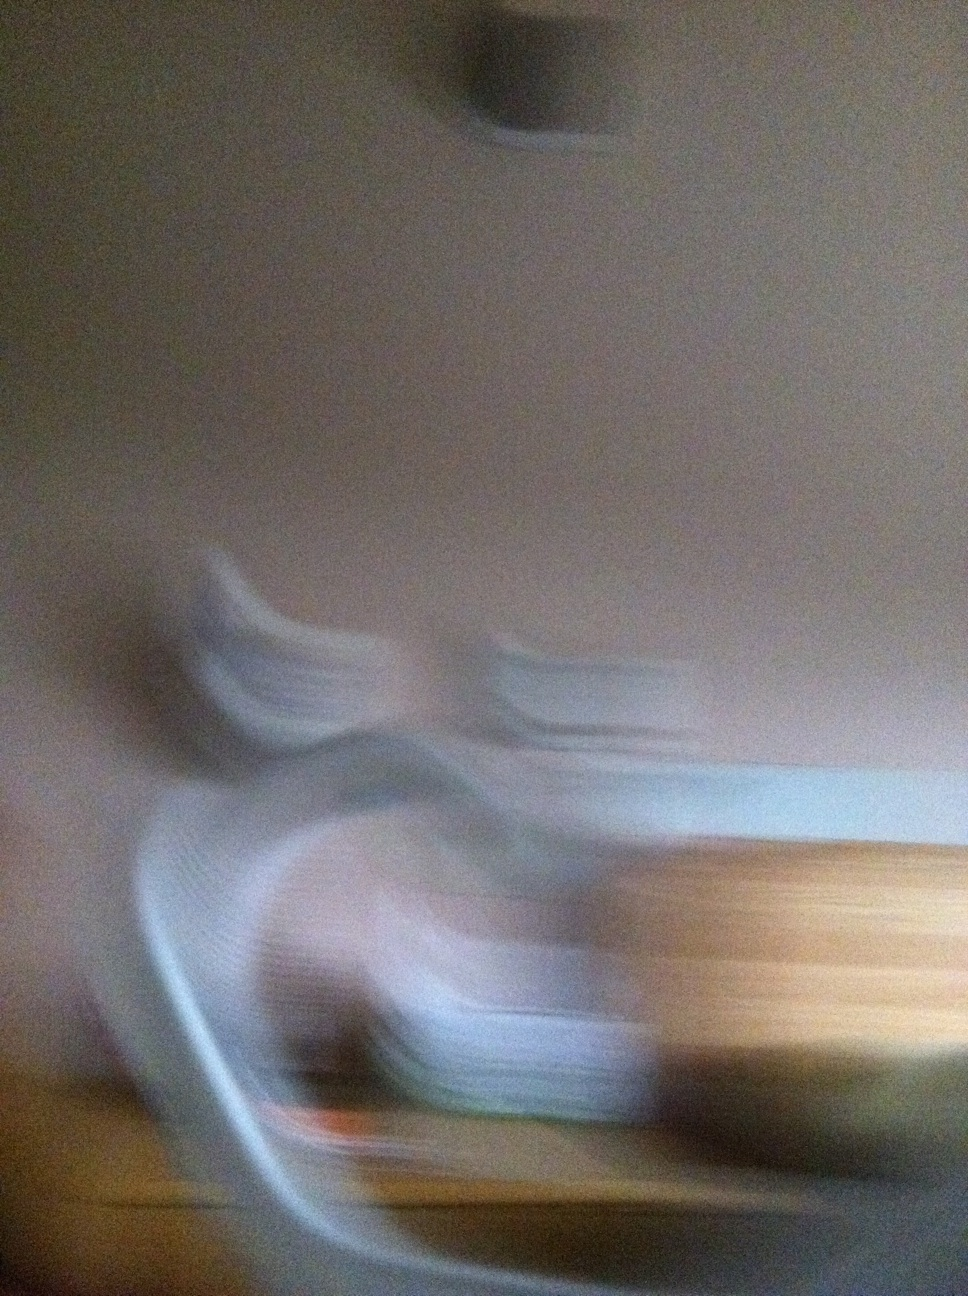Let's say this is the aftermath of a magical event. Describe what might have happened. In a quaint village surrounded by whispers of old magic, a mysterious event unfolded. At midnight, as the moon reached its zenith, a portal appeared, swirling with colors and energies unseen by human eyes. Out emerged a being of light, carrying an ancient artifact thought lost in legend. In an attempt to harness its power, the being performed a ritual that went awry. A shockwave spread through the village, blurring the dimensions and causing physical reality to warp and twist. Objects stretched, colors smeared, and time itself seemed to flutter erratically. The villagers witnessed this magical chaos with wide eyes as their world morphed into an otherworldly canvas. The next morning, the village began to return to normal, but the remnants of the magical event lingered, embodied forever in the imagery of blurred edges and blended hues, a lasting testament to the power held within the artifact. How did the villagers react to the event? The villagers were initially startled and bewildered by the event, their reality merging with the strange and the unknown. Some were filled with awe, seeing it as a divine spectacle that enriched the lore of their land. Others experienced fear, worrying about the stability of their world and the unforeseen consequences. As the blurred dimensions gradually settled, the community came together, discussing the event in hushed tones around evening fires. Elders and historians took it upon themselves to document the occurrence, ensuring that the extraordinary event would be remembered through stories and paintings, while the villagers adjusted to the subtle changes left in its wake, their lives forever marked by the brush of ancient magic. 